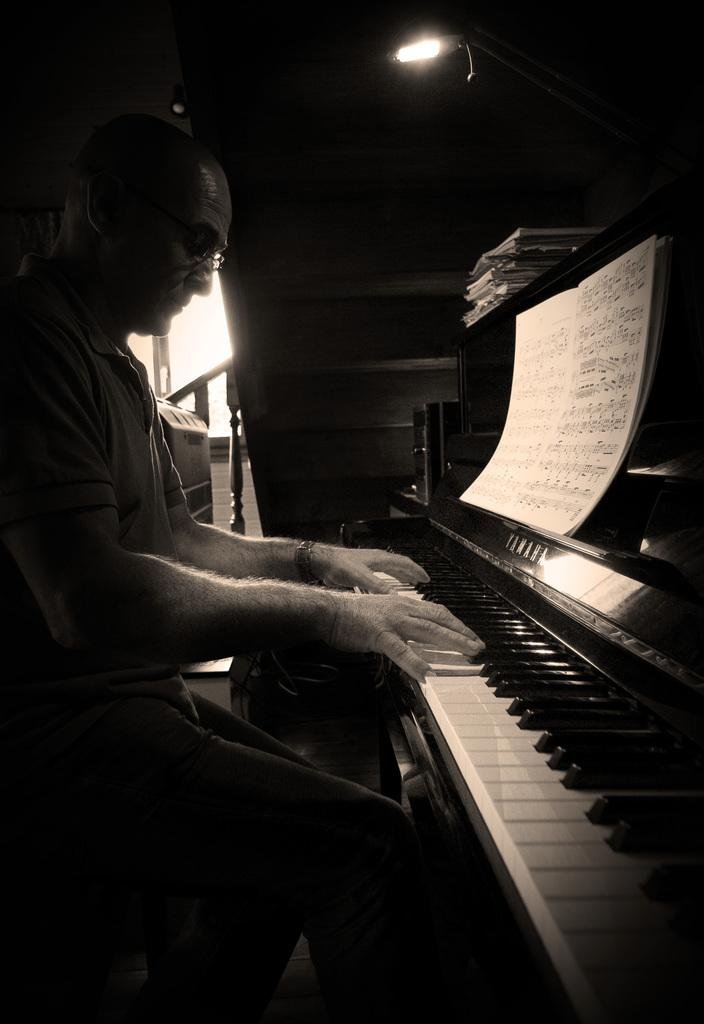Who is the person in the image? There is a man in the image. What is the man doing in the image? The man is seated and playing a piano. What object is in front of the man? There is a book in front of the man. What can be seen above the man in the image? There is a light on top in the image. What type of rake is the man using to play the piano in the image? There is no rake present in the image; the man is playing the piano with his hands. What selection of music is the man playing on the piano in the image? The image does not provide information about the specific selection of music being played by the man. 